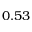Convert formula to latex. <formula><loc_0><loc_0><loc_500><loc_500>0 . 5 3</formula> 